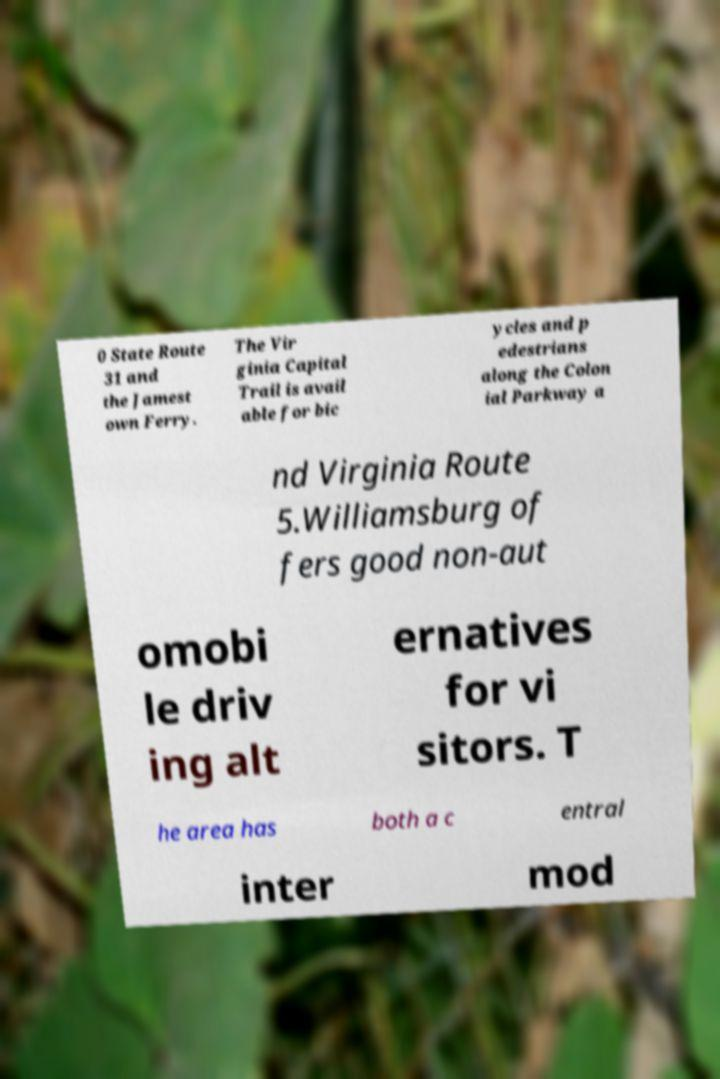Could you extract and type out the text from this image? 0 State Route 31 and the Jamest own Ferry. The Vir ginia Capital Trail is avail able for bic ycles and p edestrians along the Colon ial Parkway a nd Virginia Route 5.Williamsburg of fers good non-aut omobi le driv ing alt ernatives for vi sitors. T he area has both a c entral inter mod 